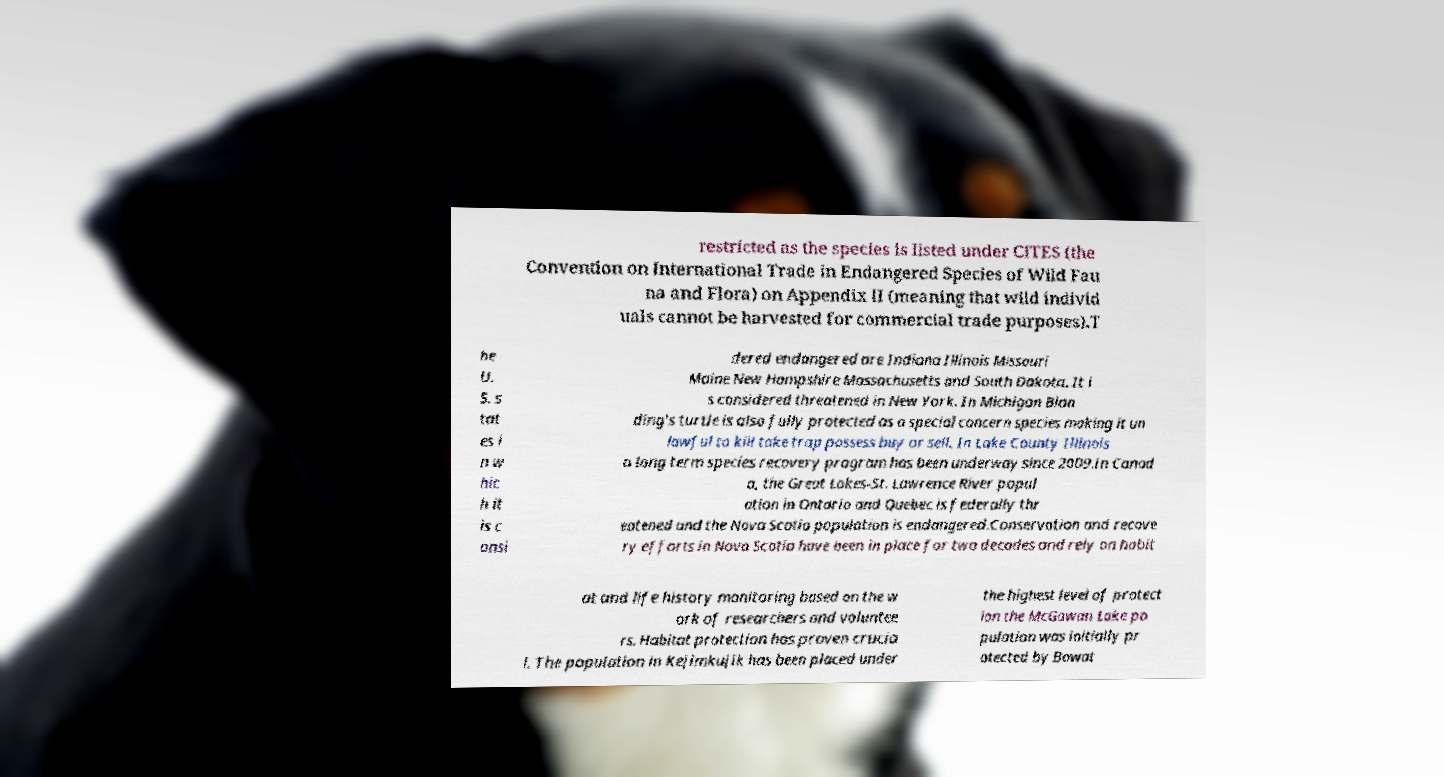Can you accurately transcribe the text from the provided image for me? restricted as the species is listed under CITES (the Convention on International Trade in Endangered Species of Wild Fau na and Flora) on Appendix II (meaning that wild individ uals cannot be harvested for commercial trade purposes).T he U. S. s tat es i n w hic h it is c onsi dered endangered are Indiana Illinois Missouri Maine New Hampshire Massachusetts and South Dakota. It i s considered threatened in New York. In Michigan Blan ding's turtle is also fully protected as a special concern species making it un lawful to kill take trap possess buy or sell. In Lake County Illinois a long term species recovery program has been underway since 2009.In Canad a, the Great Lakes-St. Lawrence River popul ation in Ontario and Quebec is federally thr eatened and the Nova Scotia population is endangered.Conservation and recove ry efforts in Nova Scotia have been in place for two decades and rely on habit at and life history monitoring based on the w ork of researchers and voluntee rs. Habitat protection has proven crucia l. The population in Kejimkujik has been placed under the highest level of protect ion the McGowan Lake po pulation was initially pr otected by Bowat 